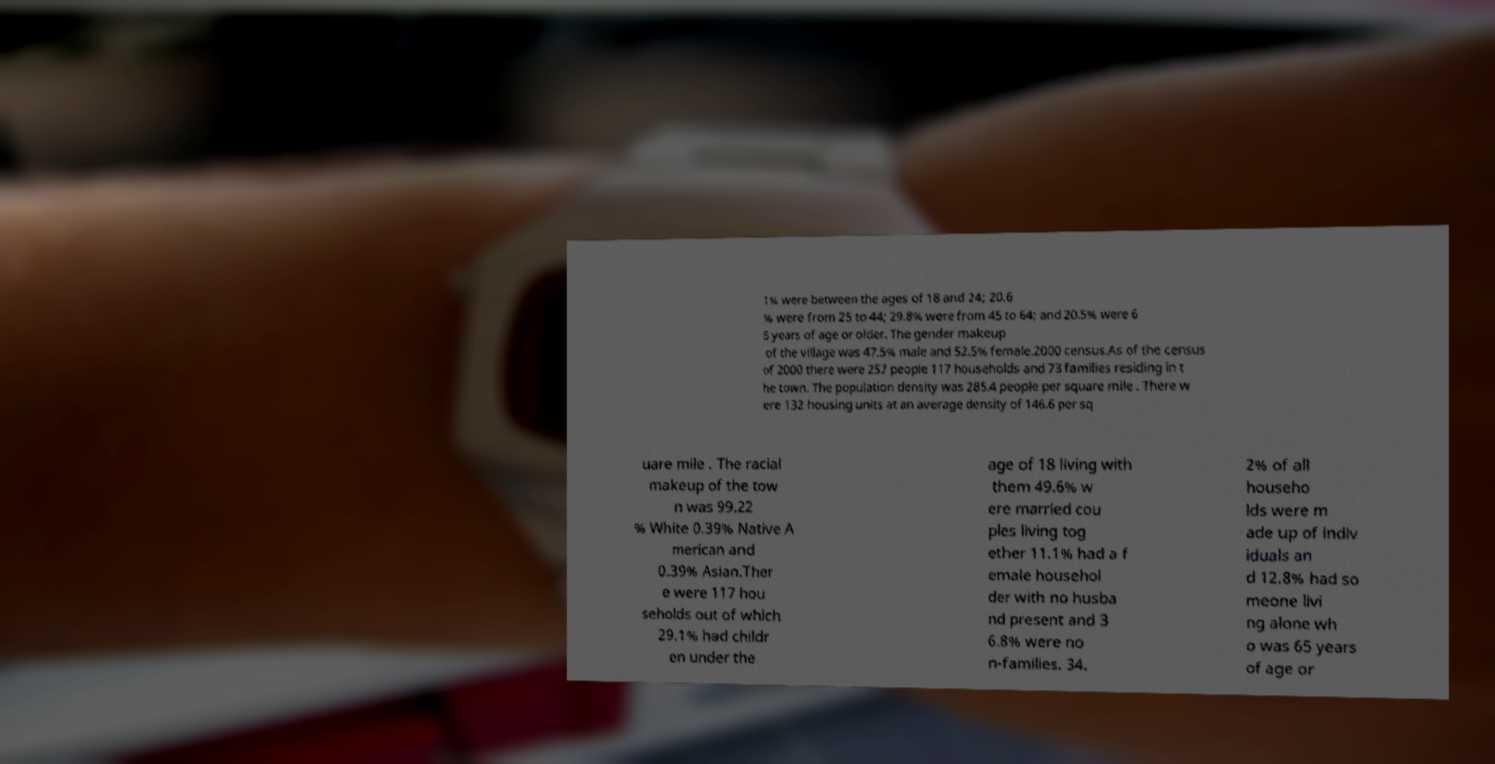What messages or text are displayed in this image? I need them in a readable, typed format. 1% were between the ages of 18 and 24; 20.6 % were from 25 to 44; 29.8% were from 45 to 64; and 20.5% were 6 5 years of age or older. The gender makeup of the village was 47.5% male and 52.5% female.2000 census.As of the census of 2000 there were 257 people 117 households and 73 families residing in t he town. The population density was 285.4 people per square mile . There w ere 132 housing units at an average density of 146.6 per sq uare mile . The racial makeup of the tow n was 99.22 % White 0.39% Native A merican and 0.39% Asian.Ther e were 117 hou seholds out of which 29.1% had childr en under the age of 18 living with them 49.6% w ere married cou ples living tog ether 11.1% had a f emale househol der with no husba nd present and 3 6.8% were no n-families. 34. 2% of all househo lds were m ade up of indiv iduals an d 12.8% had so meone livi ng alone wh o was 65 years of age or 